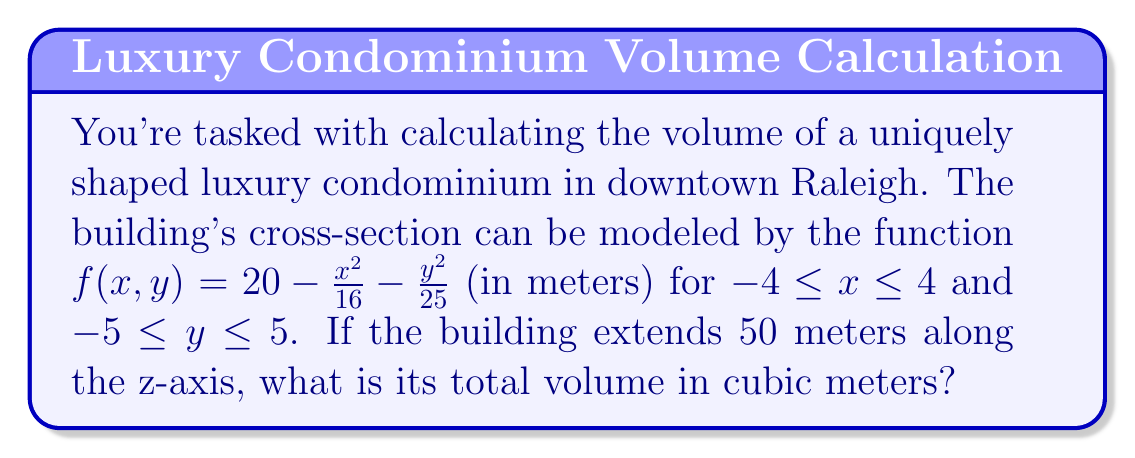Show me your answer to this math problem. To calculate the volume of this complex-shaped building, we need to use a triple integral. Here's the step-by-step process:

1) The volume is given by the triple integral:

   $$V = \int_{0}^{50} \int_{-5}^{5} \int_{-4}^{4} f(x,y) \, dx \, dy \, dz$$

2) Since the building extends uniformly along the z-axis, we can simplify this to:

   $$V = 50 \int_{-5}^{5} \int_{-4}^{4} f(x,y) \, dx \, dy$$

3) Substitute the function $f(x,y) = 20 - \frac{x^2}{16} - \frac{y^2}{25}$:

   $$V = 50 \int_{-5}^{5} \int_{-4}^{4} (20 - \frac{x^2}{16} - \frac{y^2}{25}) \, dx \, dy$$

4) Integrate with respect to x:

   $$V = 50 \int_{-5}^{5} [20x - \frac{x^3}{48} - \frac{xy^2}{25}]_{-4}^{4} \, dy$$

5) Evaluate the inner integral:

   $$V = 50 \int_{-5}^{5} (160 - \frac{64}{3} - \frac{16y^2}{25}) \, dy$$

6) Simplify:

   $$V = 50 \int_{-5}^{5} (\frac{416}{3} - \frac{16y^2}{25}) \, dy$$

7) Integrate with respect to y:

   $$V = 50 [\frac{416y}{3} - \frac{16y^3}{75}]_{-5}^{5}$$

8) Evaluate the outer integral:

   $$V = 50 (\frac{4160}{3} - \frac{4000}{75})$$

9) Simplify:

   $$V = 50 (\frac{104000}{75} - \frac{4000}{75}) = 50 \cdot \frac{100000}{75} = \frac{5000000}{75}$$
Answer: $\frac{5000000}{75} = 66666.67$ cubic meters (rounded to two decimal places) 